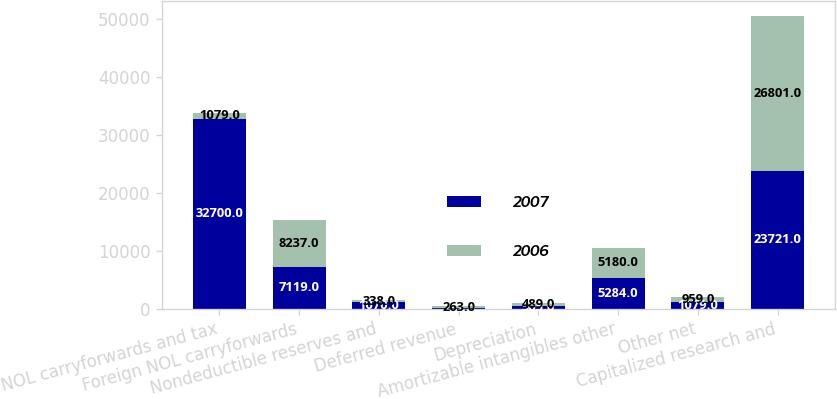Convert chart to OTSL. <chart><loc_0><loc_0><loc_500><loc_500><stacked_bar_chart><ecel><fcel>NOL carryforwards and tax<fcel>Foreign NOL carryforwards<fcel>Nondeductible reserves and<fcel>Deferred revenue<fcel>Depreciation<fcel>Amortizable intangibles other<fcel>Other net<fcel>Capitalized research and<nl><fcel>2007<fcel>32700<fcel>7119<fcel>1070<fcel>132<fcel>505<fcel>5284<fcel>1079<fcel>23721<nl><fcel>2006<fcel>1079<fcel>8237<fcel>338<fcel>263<fcel>489<fcel>5180<fcel>959<fcel>26801<nl></chart> 